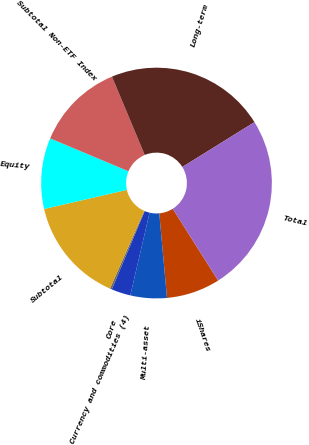Convert chart. <chart><loc_0><loc_0><loc_500><loc_500><pie_chart><fcel>iShares<fcel>Multi-asset<fcel>Core<fcel>Currency and commodities (4)<fcel>Subtotal<fcel>Equity<fcel>Subtotal Non-ETF Index<fcel>Long-term<fcel>Total<nl><fcel>7.52%<fcel>5.1%<fcel>2.69%<fcel>0.27%<fcel>14.78%<fcel>9.94%<fcel>12.36%<fcel>22.46%<fcel>24.88%<nl></chart> 